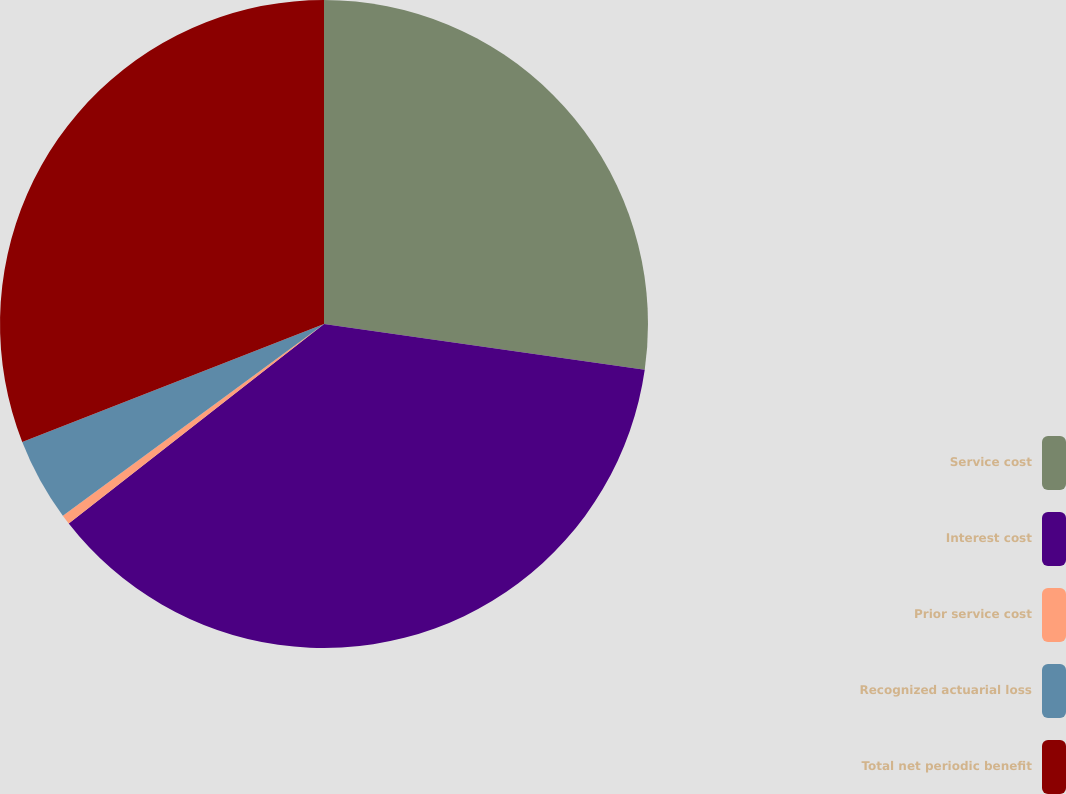Convert chart to OTSL. <chart><loc_0><loc_0><loc_500><loc_500><pie_chart><fcel>Service cost<fcel>Interest cost<fcel>Prior service cost<fcel>Recognized actuarial loss<fcel>Total net periodic benefit<nl><fcel>27.26%<fcel>37.18%<fcel>0.48%<fcel>4.15%<fcel>30.93%<nl></chart> 